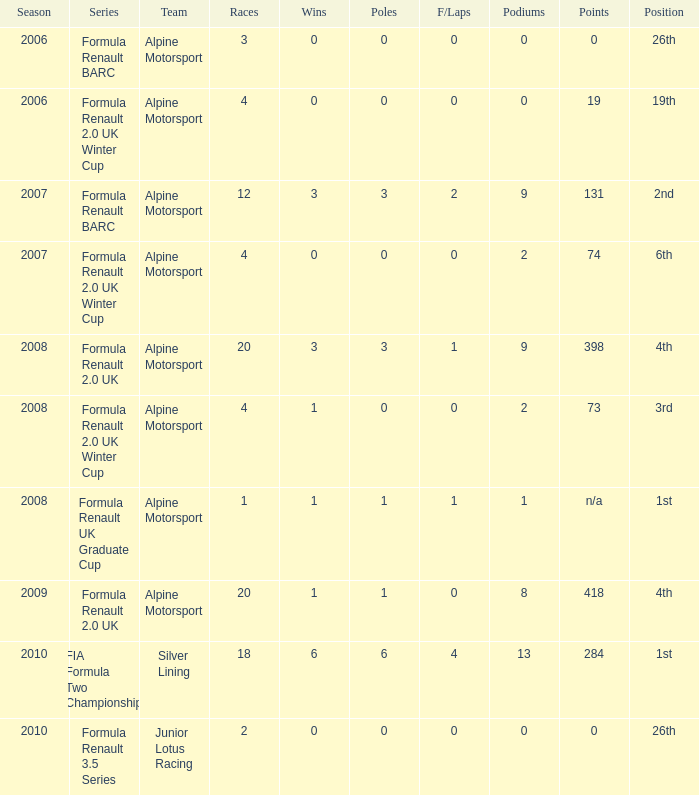For which races were there no fastest laps and a single pole position? 20.0. 